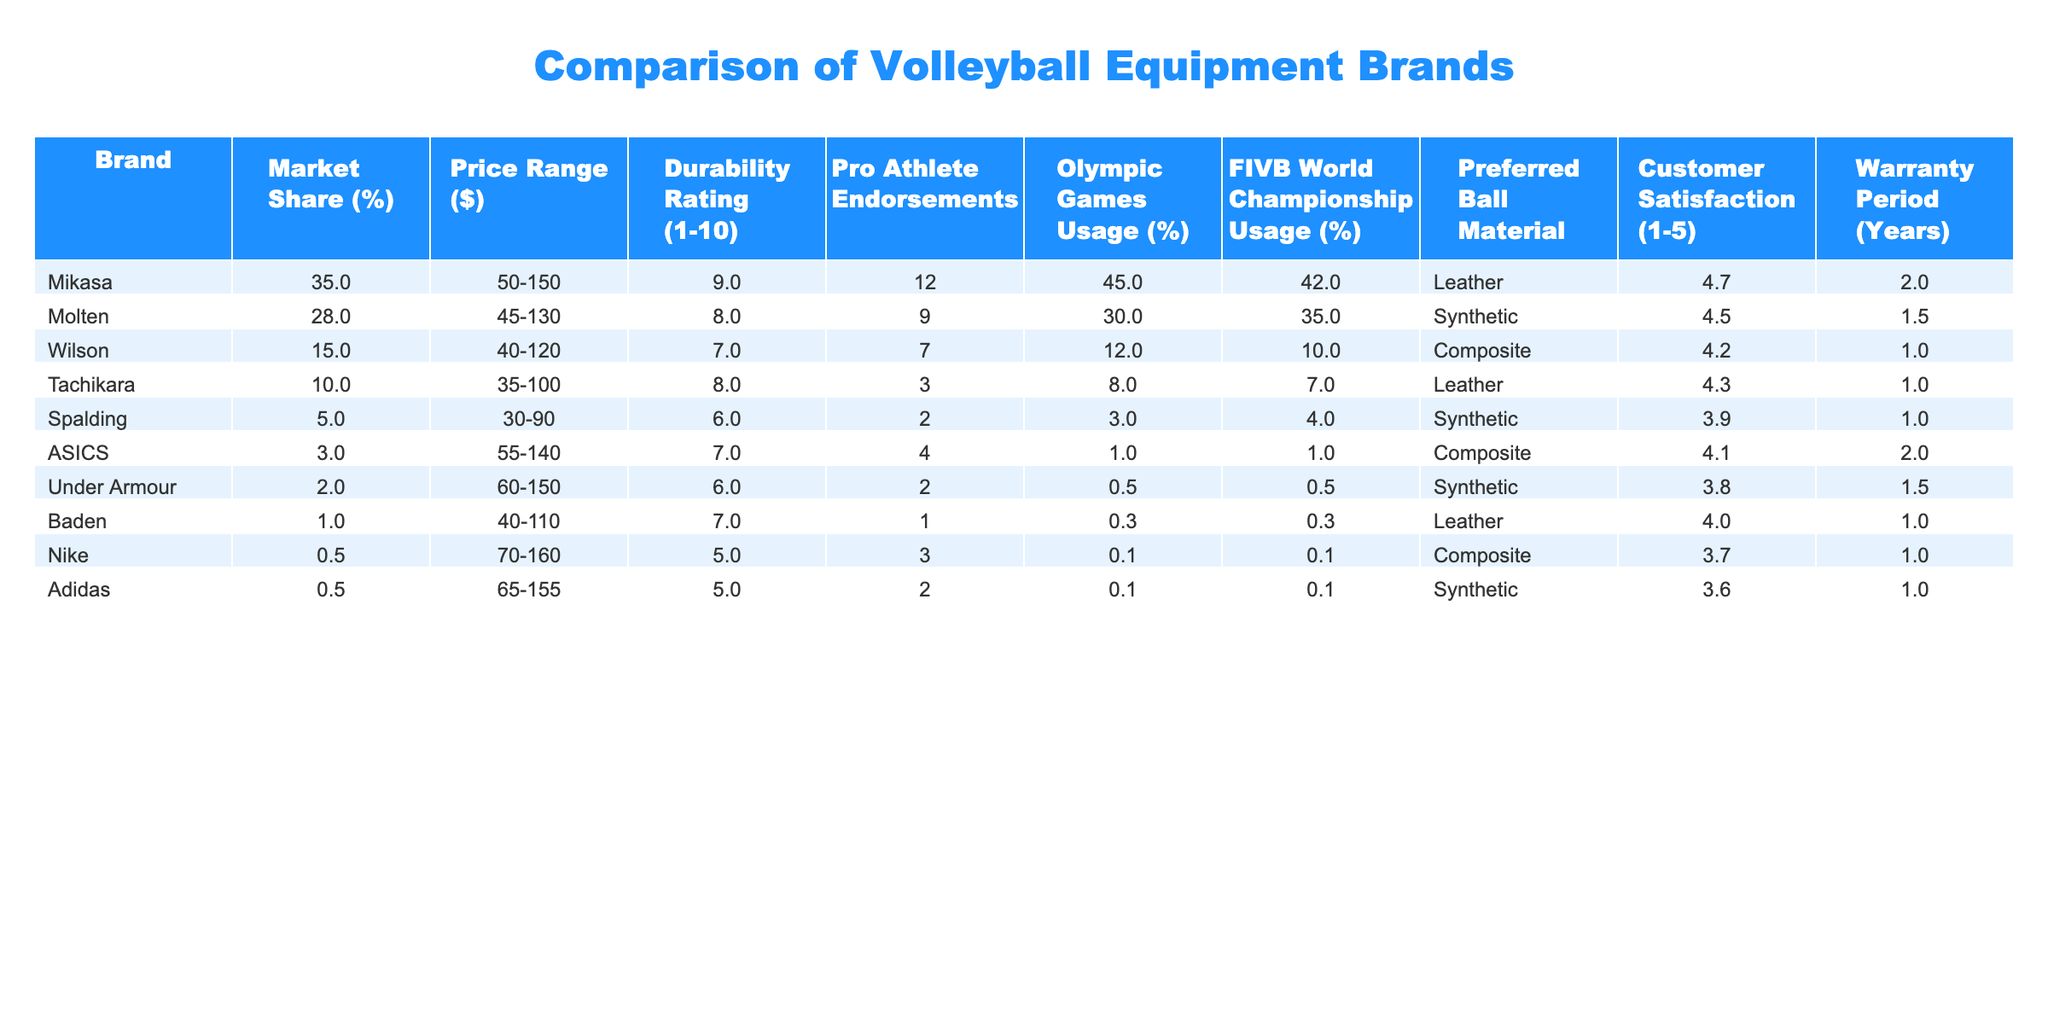What is the market share of Mikasa? According to the table, Mikasa has a market share of 35%.
Answer: 35% Which brand has the highest durability rating? The table shows that Mikasa has the highest durability rating of 9 out of 10.
Answer: Mikasa What is the price range for the brand with the lowest market share? Baden, which has the lowest market share of 1%, has a price range of $40 to $110.
Answer: $40 to $110 How many years of warranty does Molten offer? Looking at the table, Molten has a warranty period of 1.5 years.
Answer: 1.5 years Did Under Armour have more endorsements than ASICS? According to the table, Under Armour has 2 endorsements while ASICS has 4, so Under Armour did not have more endorsements.
Answer: No What is the average customer satisfaction rating for brands with leather as the preferred ball material? The brands with leather are Mikasa (4.7), Tachikara (4.3), and Baden (4.0). The average is (4.7 + 4.3 + 4.0) / 3 = 4.33.
Answer: 4.33 How much market share do the top three brands hold combined? The top three brands are Mikasa (35%), Molten (28%), and Wilson (15%), so combined they have 35 + 28 + 15 = 78% market share.
Answer: 78% Is there any brand that offers a warranty period of 2 years or more? The table indicates that both Mikasa and ASICS offer a warranty period of 2 years.
Answer: Yes Can you find a brand that has both a price range over $100 and a durability rating of 8 or more? The brands that meet this criteria are Mikasa (price range $50-150, durability 9) and Molten (price range $45-130, durability 8).
Answer: Yes Which brand has the lowest customer satisfaction rating? The table indicates that Spalding has the lowest customer satisfaction rating of 3.9.
Answer: Spalding 